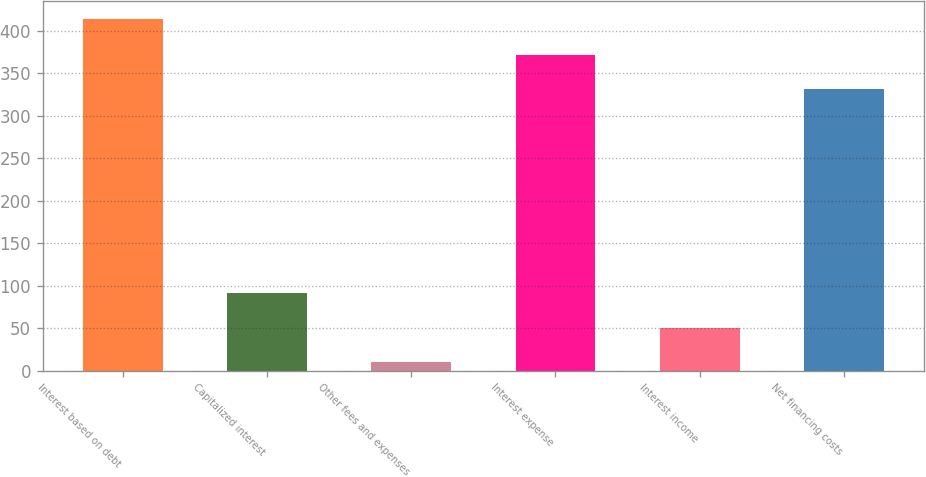Convert chart to OTSL. <chart><loc_0><loc_0><loc_500><loc_500><bar_chart><fcel>Interest based on debt<fcel>Capitalized interest<fcel>Other fees and expenses<fcel>Interest expense<fcel>Interest income<fcel>Net financing costs<nl><fcel>414<fcel>90.8<fcel>10<fcel>371.4<fcel>50.4<fcel>331<nl></chart> 